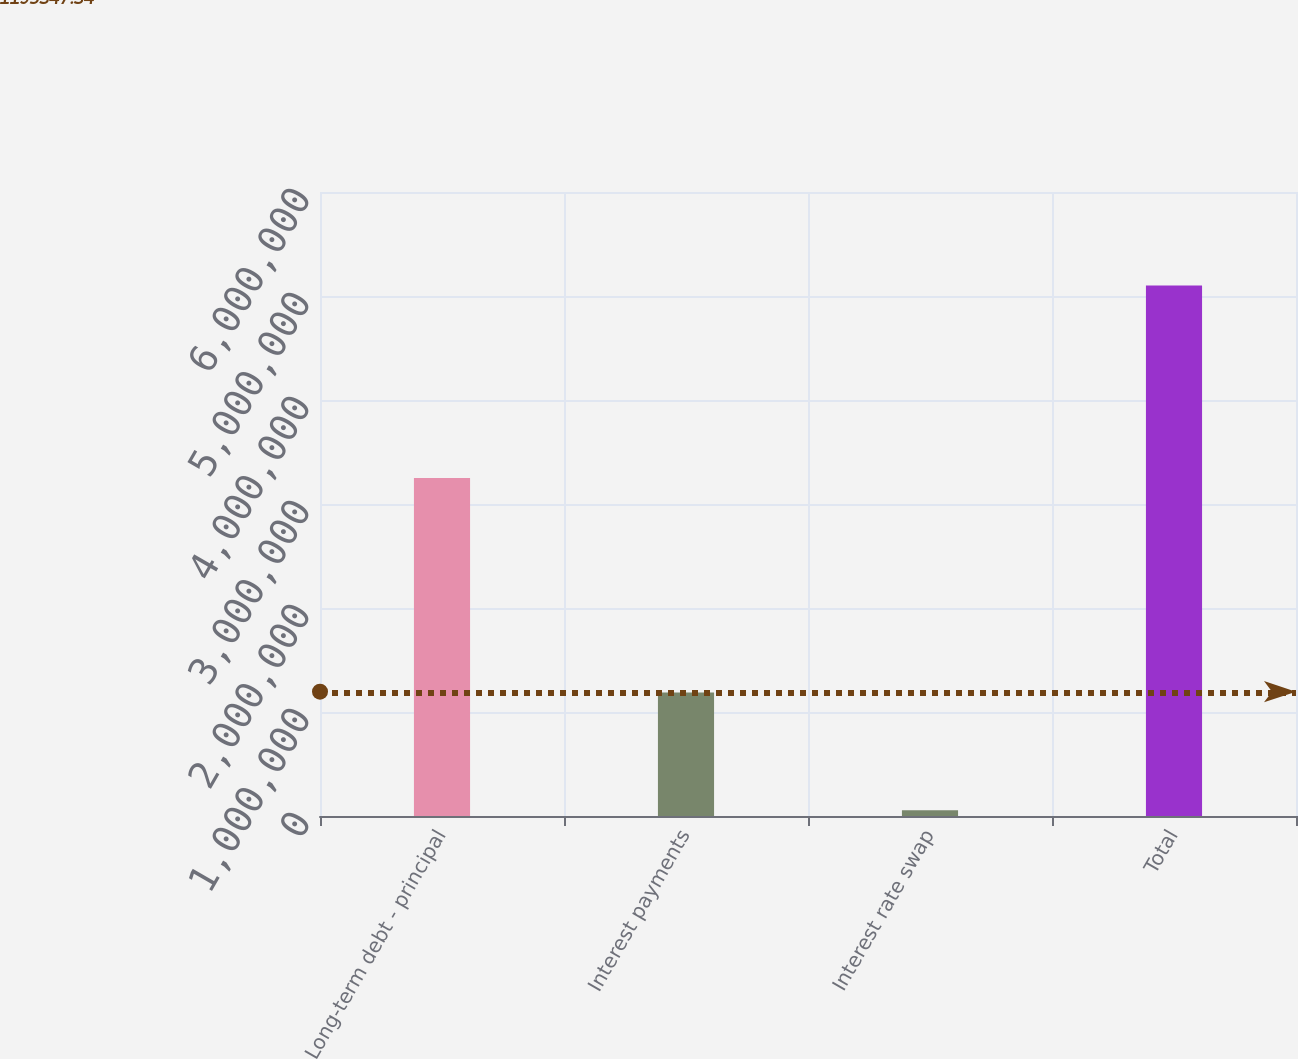Convert chart. <chart><loc_0><loc_0><loc_500><loc_500><bar_chart><fcel>Long-term debt - principal<fcel>Interest payments<fcel>Interest rate swap<fcel>Total<nl><fcel>3.25e+06<fcel>1.18797e+06<fcel>55534<fcel>5.10181e+06<nl></chart> 